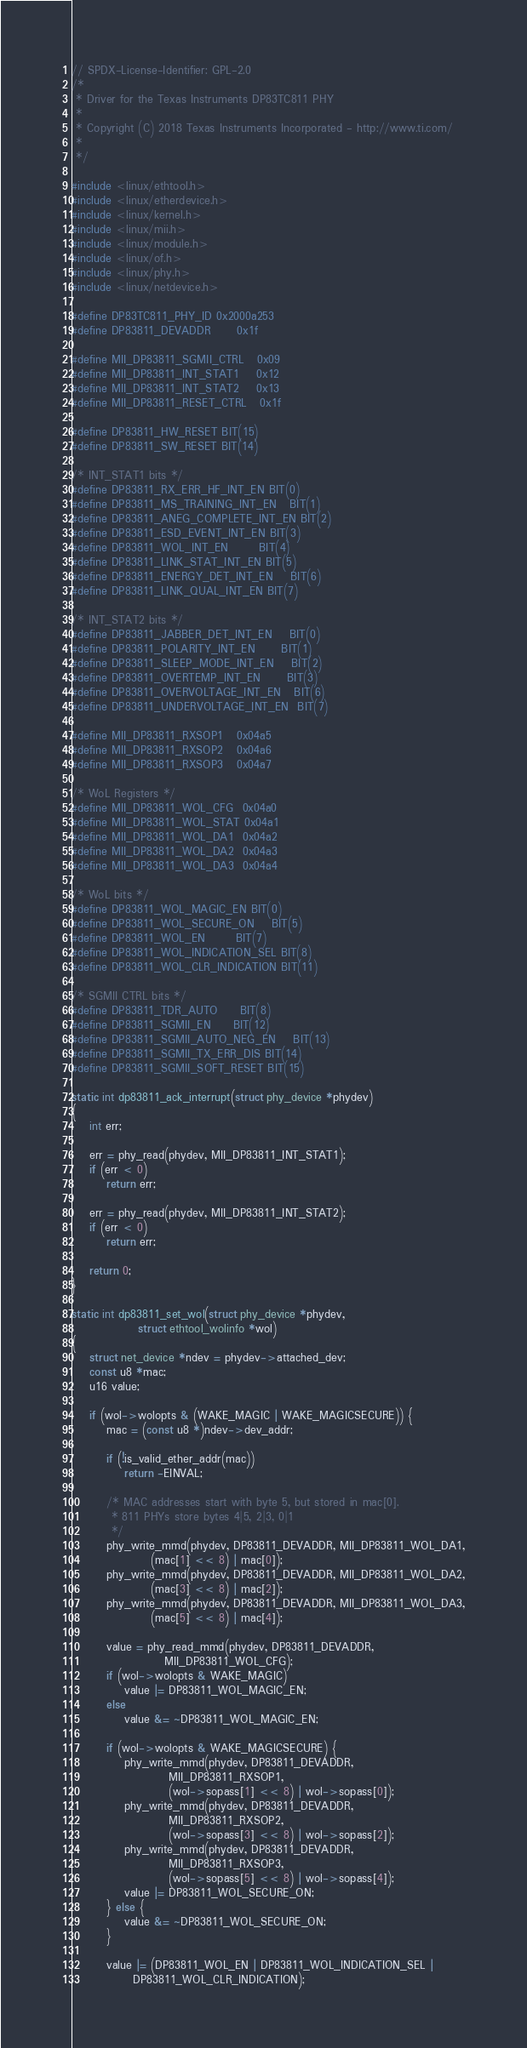Convert code to text. <code><loc_0><loc_0><loc_500><loc_500><_C_>// SPDX-License-Identifier: GPL-2.0
/*
 * Driver for the Texas Instruments DP83TC811 PHY
 *
 * Copyright (C) 2018 Texas Instruments Incorporated - http://www.ti.com/
 *
 */

#include <linux/ethtool.h>
#include <linux/etherdevice.h>
#include <linux/kernel.h>
#include <linux/mii.h>
#include <linux/module.h>
#include <linux/of.h>
#include <linux/phy.h>
#include <linux/netdevice.h>

#define DP83TC811_PHY_ID	0x2000a253
#define DP83811_DEVADDR		0x1f

#define MII_DP83811_SGMII_CTRL	0x09
#define MII_DP83811_INT_STAT1	0x12
#define MII_DP83811_INT_STAT2	0x13
#define MII_DP83811_RESET_CTRL	0x1f

#define DP83811_HW_RESET	BIT(15)
#define DP83811_SW_RESET	BIT(14)

/* INT_STAT1 bits */
#define DP83811_RX_ERR_HF_INT_EN	BIT(0)
#define DP83811_MS_TRAINING_INT_EN	BIT(1)
#define DP83811_ANEG_COMPLETE_INT_EN	BIT(2)
#define DP83811_ESD_EVENT_INT_EN	BIT(3)
#define DP83811_WOL_INT_EN		BIT(4)
#define DP83811_LINK_STAT_INT_EN	BIT(5)
#define DP83811_ENERGY_DET_INT_EN	BIT(6)
#define DP83811_LINK_QUAL_INT_EN	BIT(7)

/* INT_STAT2 bits */
#define DP83811_JABBER_DET_INT_EN	BIT(0)
#define DP83811_POLARITY_INT_EN		BIT(1)
#define DP83811_SLEEP_MODE_INT_EN	BIT(2)
#define DP83811_OVERTEMP_INT_EN		BIT(3)
#define DP83811_OVERVOLTAGE_INT_EN	BIT(6)
#define DP83811_UNDERVOLTAGE_INT_EN	BIT(7)

#define MII_DP83811_RXSOP1	0x04a5
#define MII_DP83811_RXSOP2	0x04a6
#define MII_DP83811_RXSOP3	0x04a7

/* WoL Registers */
#define MII_DP83811_WOL_CFG	0x04a0
#define MII_DP83811_WOL_STAT	0x04a1
#define MII_DP83811_WOL_DA1	0x04a2
#define MII_DP83811_WOL_DA2	0x04a3
#define MII_DP83811_WOL_DA3	0x04a4

/* WoL bits */
#define DP83811_WOL_MAGIC_EN	BIT(0)
#define DP83811_WOL_SECURE_ON	BIT(5)
#define DP83811_WOL_EN		BIT(7)
#define DP83811_WOL_INDICATION_SEL BIT(8)
#define DP83811_WOL_CLR_INDICATION BIT(11)

/* SGMII CTRL bits */
#define DP83811_TDR_AUTO		BIT(8)
#define DP83811_SGMII_EN		BIT(12)
#define DP83811_SGMII_AUTO_NEG_EN	BIT(13)
#define DP83811_SGMII_TX_ERR_DIS	BIT(14)
#define DP83811_SGMII_SOFT_RESET	BIT(15)

static int dp83811_ack_interrupt(struct phy_device *phydev)
{
	int err;

	err = phy_read(phydev, MII_DP83811_INT_STAT1);
	if (err < 0)
		return err;

	err = phy_read(phydev, MII_DP83811_INT_STAT2);
	if (err < 0)
		return err;

	return 0;
}

static int dp83811_set_wol(struct phy_device *phydev,
			   struct ethtool_wolinfo *wol)
{
	struct net_device *ndev = phydev->attached_dev;
	const u8 *mac;
	u16 value;

	if (wol->wolopts & (WAKE_MAGIC | WAKE_MAGICSECURE)) {
		mac = (const u8 *)ndev->dev_addr;

		if (!is_valid_ether_addr(mac))
			return -EINVAL;

		/* MAC addresses start with byte 5, but stored in mac[0].
		 * 811 PHYs store bytes 4|5, 2|3, 0|1
		 */
		phy_write_mmd(phydev, DP83811_DEVADDR, MII_DP83811_WOL_DA1,
			      (mac[1] << 8) | mac[0]);
		phy_write_mmd(phydev, DP83811_DEVADDR, MII_DP83811_WOL_DA2,
			      (mac[3] << 8) | mac[2]);
		phy_write_mmd(phydev, DP83811_DEVADDR, MII_DP83811_WOL_DA3,
			      (mac[5] << 8) | mac[4]);

		value = phy_read_mmd(phydev, DP83811_DEVADDR,
				     MII_DP83811_WOL_CFG);
		if (wol->wolopts & WAKE_MAGIC)
			value |= DP83811_WOL_MAGIC_EN;
		else
			value &= ~DP83811_WOL_MAGIC_EN;

		if (wol->wolopts & WAKE_MAGICSECURE) {
			phy_write_mmd(phydev, DP83811_DEVADDR,
				      MII_DP83811_RXSOP1,
				      (wol->sopass[1] << 8) | wol->sopass[0]);
			phy_write_mmd(phydev, DP83811_DEVADDR,
				      MII_DP83811_RXSOP2,
				      (wol->sopass[3] << 8) | wol->sopass[2]);
			phy_write_mmd(phydev, DP83811_DEVADDR,
				      MII_DP83811_RXSOP3,
				      (wol->sopass[5] << 8) | wol->sopass[4]);
			value |= DP83811_WOL_SECURE_ON;
		} else {
			value &= ~DP83811_WOL_SECURE_ON;
		}

		value |= (DP83811_WOL_EN | DP83811_WOL_INDICATION_SEL |
			  DP83811_WOL_CLR_INDICATION);</code> 